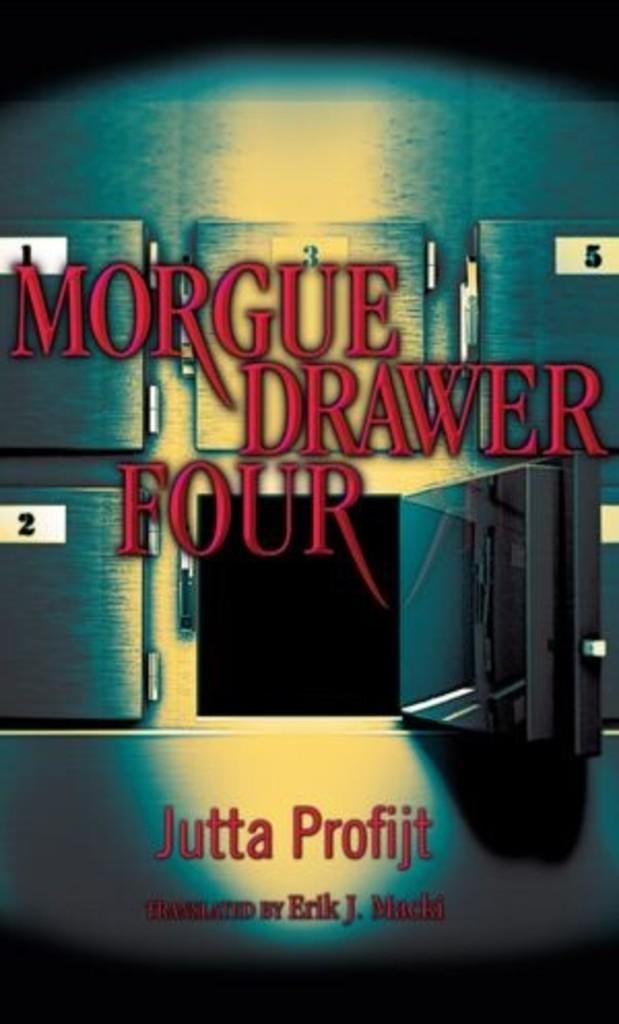What is the author's name?
Provide a short and direct response. Jutta profijt. What is the title?
Give a very brief answer. Morgue drawer four. 